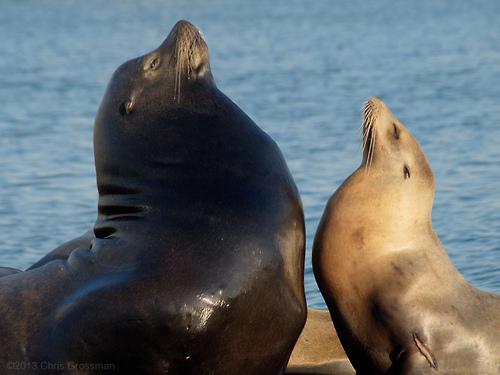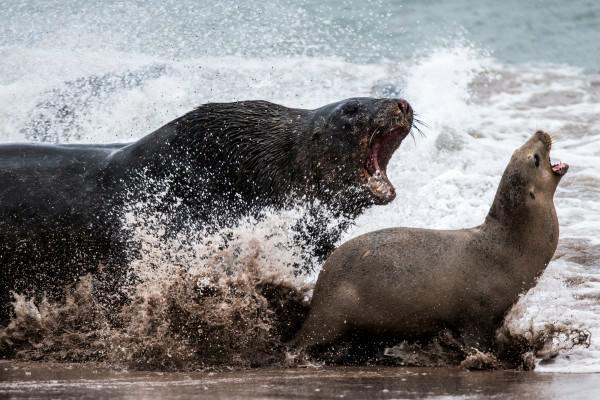The first image is the image on the left, the second image is the image on the right. Considering the images on both sides, is "There are exactly two animals in the image on the right." valid? Answer yes or no. Yes. 